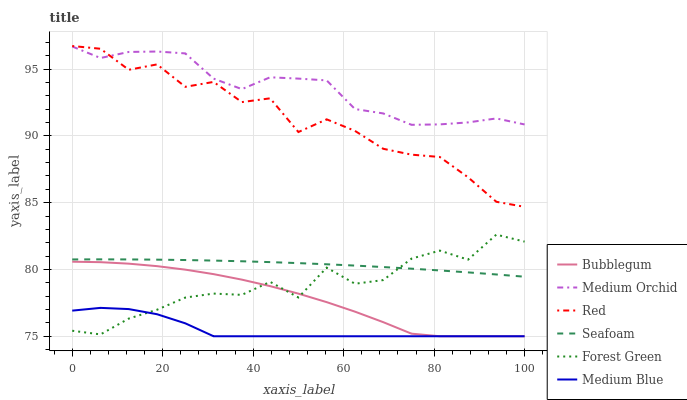Does Medium Blue have the minimum area under the curve?
Answer yes or no. Yes. Does Medium Orchid have the maximum area under the curve?
Answer yes or no. Yes. Does Seafoam have the minimum area under the curve?
Answer yes or no. No. Does Seafoam have the maximum area under the curve?
Answer yes or no. No. Is Seafoam the smoothest?
Answer yes or no. Yes. Is Red the roughest?
Answer yes or no. Yes. Is Medium Blue the smoothest?
Answer yes or no. No. Is Medium Blue the roughest?
Answer yes or no. No. Does Seafoam have the lowest value?
Answer yes or no. No. Does Red have the highest value?
Answer yes or no. Yes. Does Seafoam have the highest value?
Answer yes or no. No. Is Medium Blue less than Red?
Answer yes or no. Yes. Is Medium Orchid greater than Seafoam?
Answer yes or no. Yes. Does Bubblegum intersect Medium Blue?
Answer yes or no. Yes. Is Bubblegum less than Medium Blue?
Answer yes or no. No. Is Bubblegum greater than Medium Blue?
Answer yes or no. No. Does Medium Blue intersect Red?
Answer yes or no. No. 